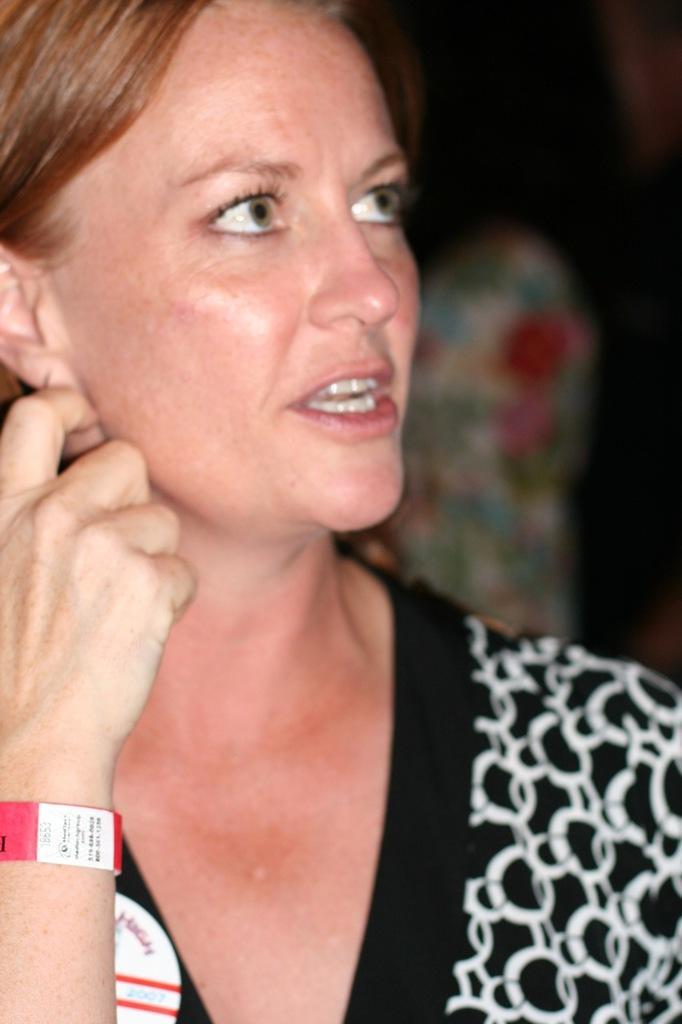Can you describe this image briefly? This is the image of a person she is wearing a black and white top, she has brown hair. And the background is blurred. 